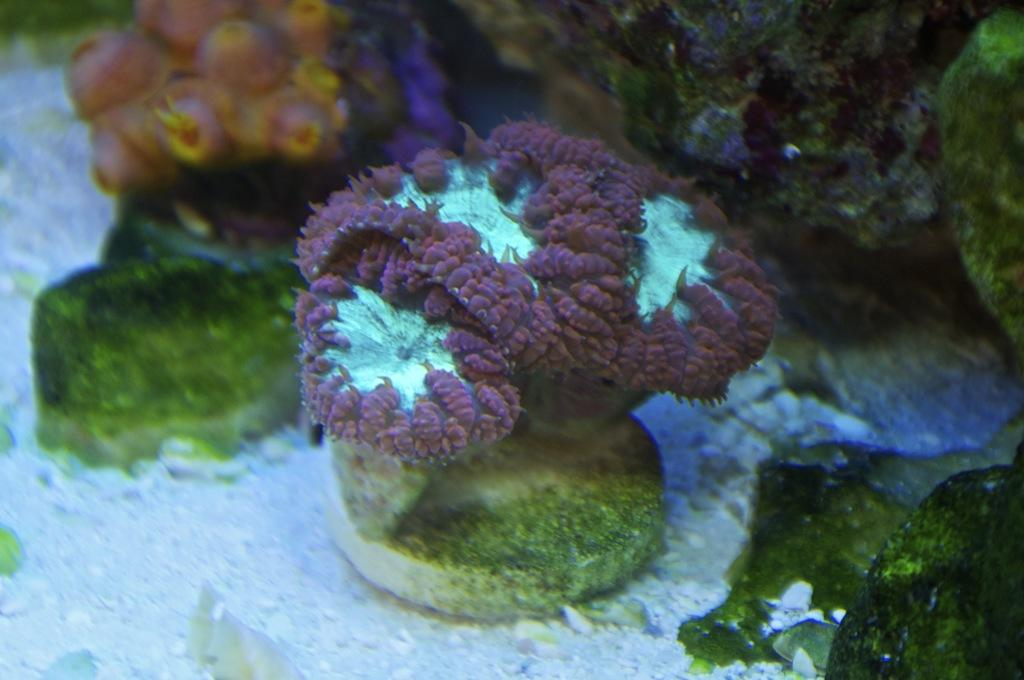What type of plants are visible in the image? There are water plants in the image. What type of mountain can be seen in the background of the image? There is no mountain present in the image; it only features water plants. 